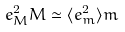<formula> <loc_0><loc_0><loc_500><loc_500>e _ { M } ^ { 2 } M \simeq \langle e _ { m } ^ { 2 } \rangle m</formula> 